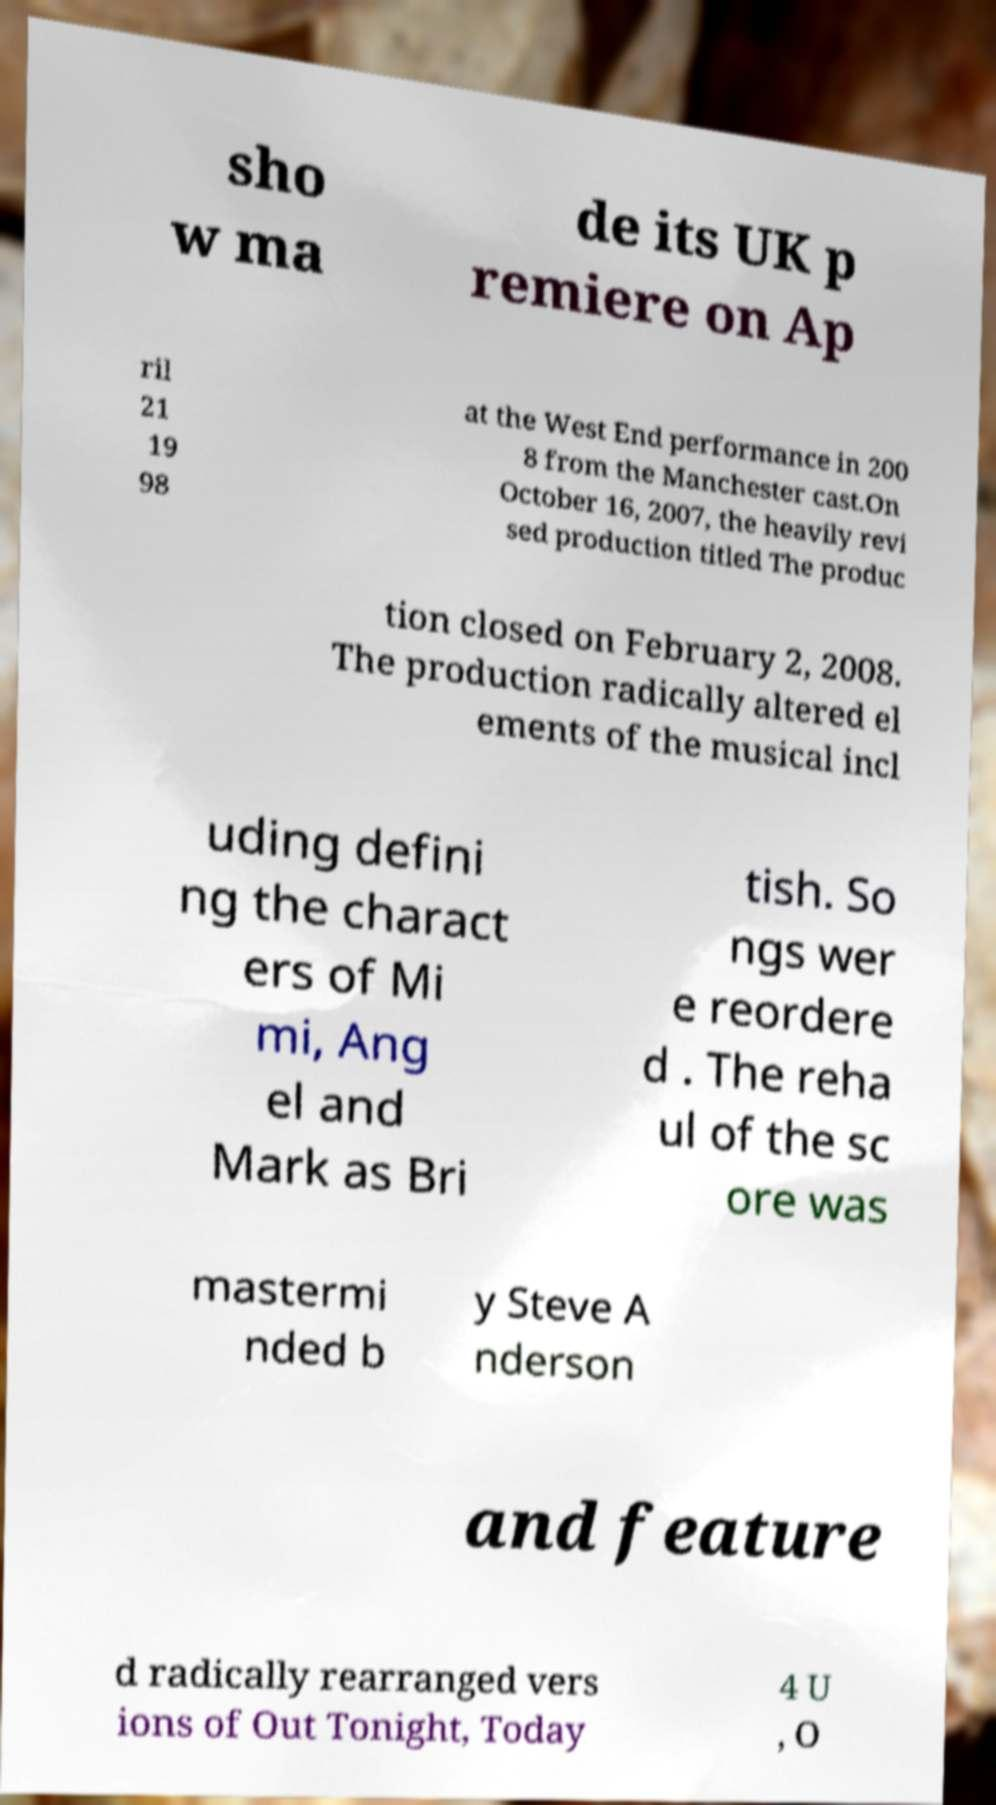Can you accurately transcribe the text from the provided image for me? sho w ma de its UK p remiere on Ap ril 21 19 98 at the West End performance in 200 8 from the Manchester cast.On October 16, 2007, the heavily revi sed production titled The produc tion closed on February 2, 2008. The production radically altered el ements of the musical incl uding defini ng the charact ers of Mi mi, Ang el and Mark as Bri tish. So ngs wer e reordere d . The reha ul of the sc ore was mastermi nded b y Steve A nderson and feature d radically rearranged vers ions of Out Tonight, Today 4 U , O 